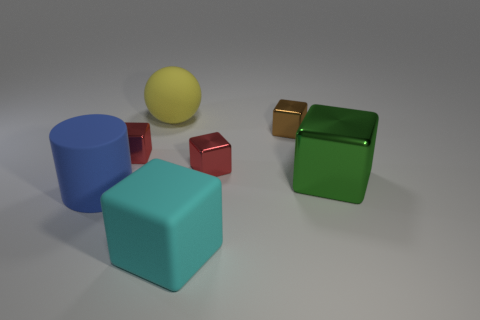Subtract all green cubes. How many cubes are left? 4 Subtract all large rubber cubes. How many cubes are left? 4 Subtract all purple blocks. Subtract all green cylinders. How many blocks are left? 5 Add 2 large green metal cubes. How many objects exist? 9 Subtract all cylinders. How many objects are left? 6 Add 7 cyan matte objects. How many cyan matte objects are left? 8 Add 2 big blue cylinders. How many big blue cylinders exist? 3 Subtract 1 blue cylinders. How many objects are left? 6 Subtract all big metallic cubes. Subtract all red things. How many objects are left? 4 